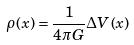<formula> <loc_0><loc_0><loc_500><loc_500>\rho ( x ) = \frac { 1 } { 4 \pi G } \Delta V ( x )</formula> 